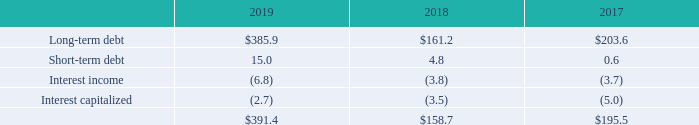Notes to Consolidated Financial Statements - (Continued) Fiscal Years Ended May 26, 2019, May 27, 2018, and May 28, 2017 (columnar dollars in millions except per share amounts) General
The Revolving Credit Facility (as defined in Note 5) and the Term Loan Agreement generally require our ratio of earnings before interest, taxes, depreciation and amortization ("EBITDA") to interest expense not to be less than 3.0 to 1.0 and our ratio of funded debt to EBITDA not to exceed certain decreasing specified levels, ranging from 5.875 through the first quarter of fiscal 2020 to 3.75 from the second quarter of fiscal 2023 and thereafter, with each ratio to be calculated on a rolling fourquarter basis. As of May 26, 2019, we were in compliance with all financial covenants under the Revolving Credit Facility and the Term Loan Agreement.
Net interest expense consists of:
Interest paid from continuing operations was $375.6 million, $164.5 million, and $223.7 million in fiscal 2019, 2018, and 2017, respectively.
What is the required ratio of earnings before interest, taxes, depreciation, and amortization ("EBITDA") to interest expense by The Revolving Credit Facility and the Term Loan Agreement? Not to be less than 3.0 to 1.0. What were the interests paid from continuing operations in the fiscal year 2017 and 2018, respectively? $223.7 million, $164.5 million. What were the net interest expenses of short-term debt in the fiscal year 2018 and 2019, respectively?
Answer scale should be: million. 4.8, 15.0. What is the ratio of net interest expense of long-term debt to interest paid from continuing operations in 2019? 385.9/375.6 
Answer: 1.03. Which year has the highest total net interest expense? 391.4>195.5>158.7
Answer: 2019. What is the percentage change in net interest expense of long-term debt from 2018 to 2019?
Answer scale should be: percent. (385.9-161.2)/161.2 
Answer: 139.39. 